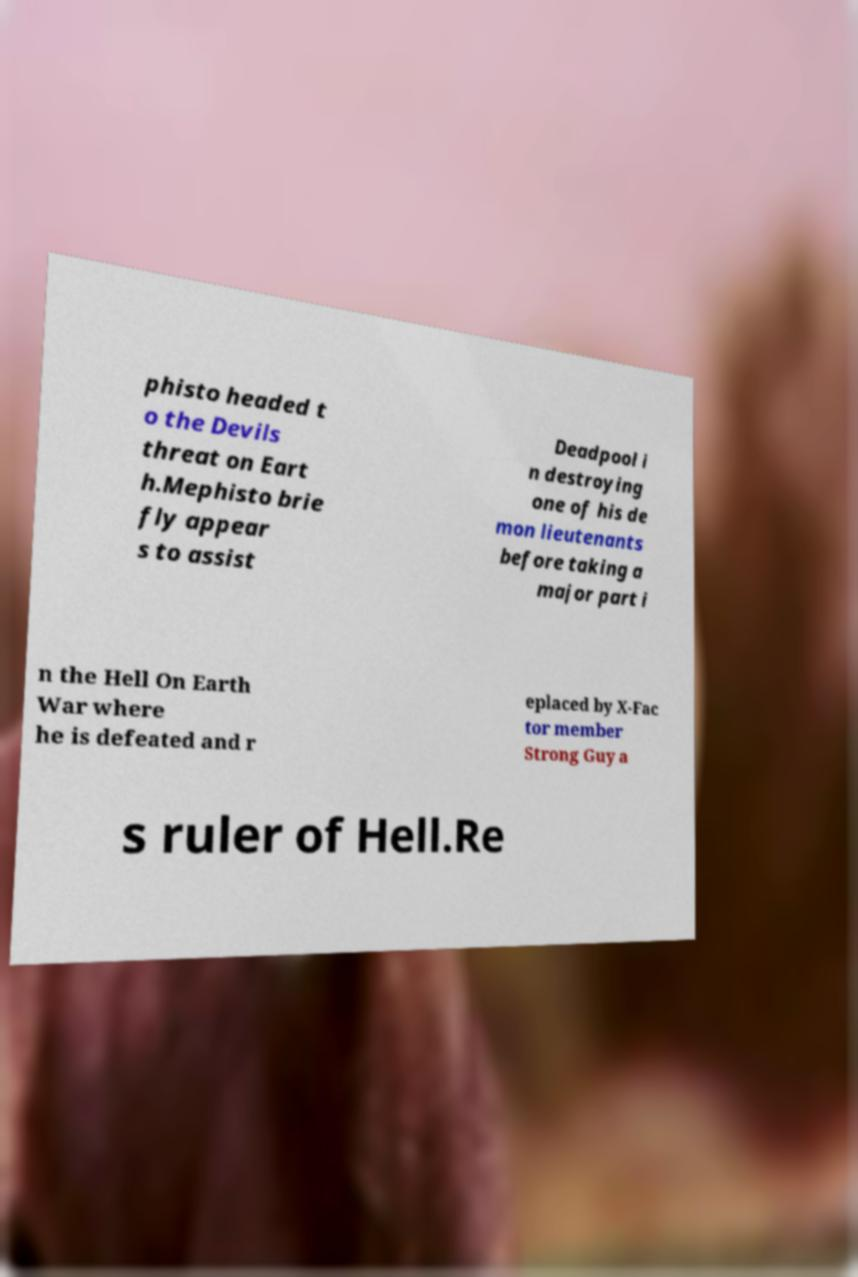There's text embedded in this image that I need extracted. Can you transcribe it verbatim? phisto headed t o the Devils threat on Eart h.Mephisto brie fly appear s to assist Deadpool i n destroying one of his de mon lieutenants before taking a major part i n the Hell On Earth War where he is defeated and r eplaced by X-Fac tor member Strong Guy a s ruler of Hell.Re 